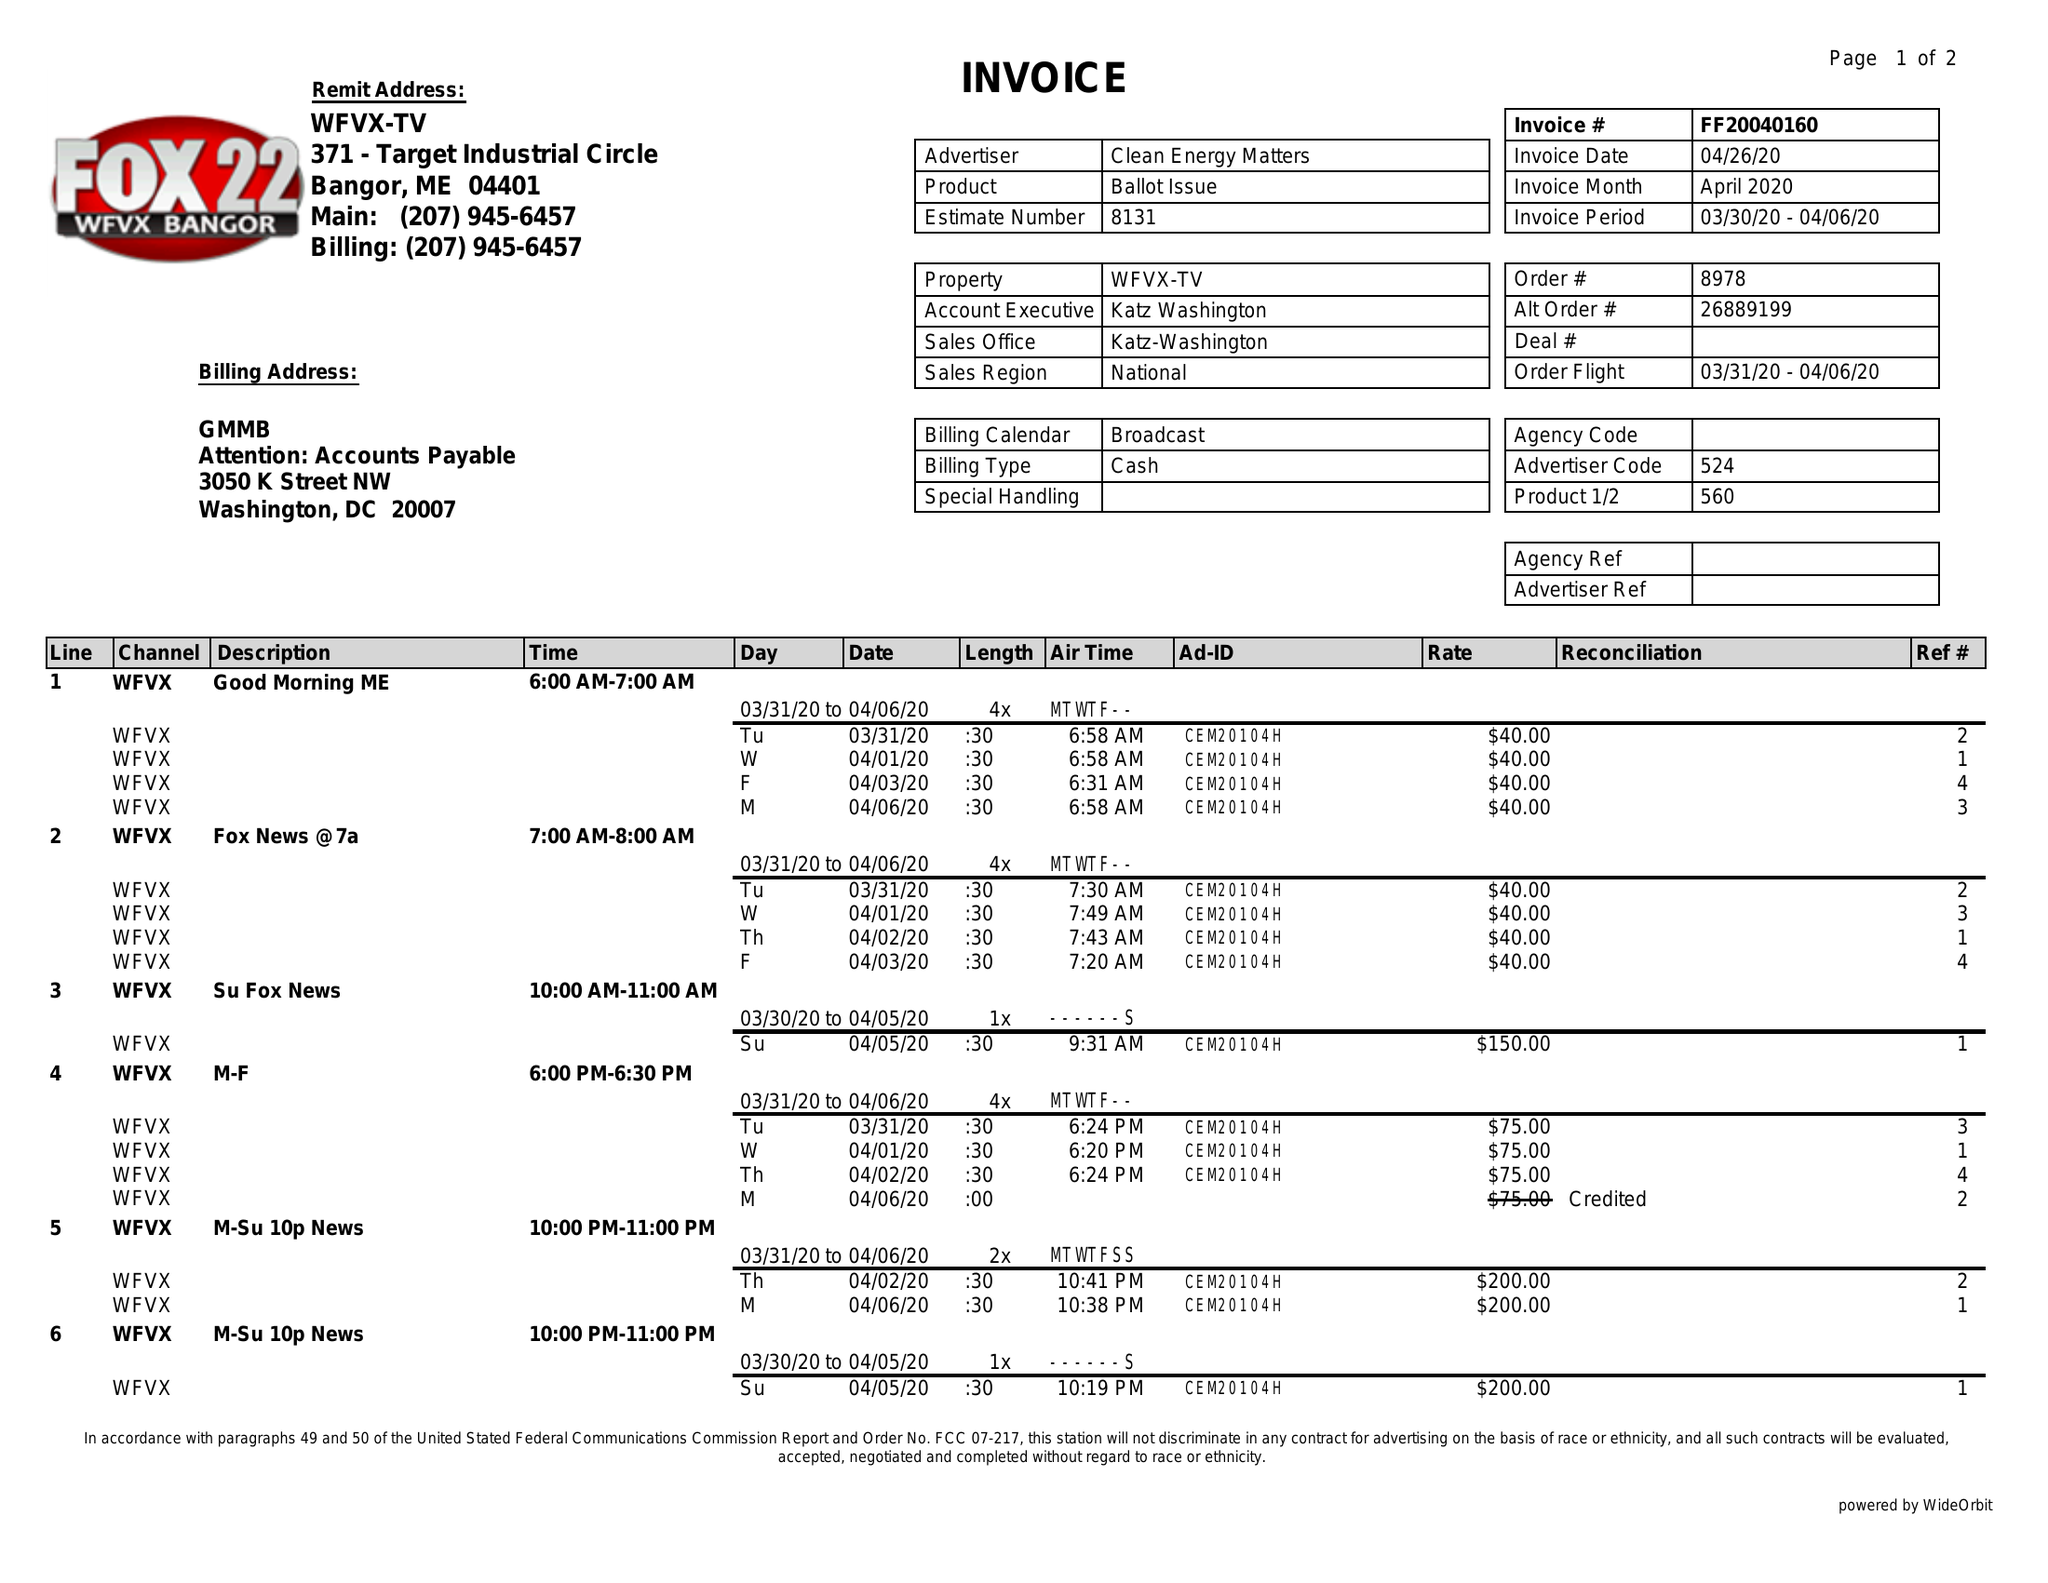What is the value for the contract_num?
Answer the question using a single word or phrase. FF20040160 